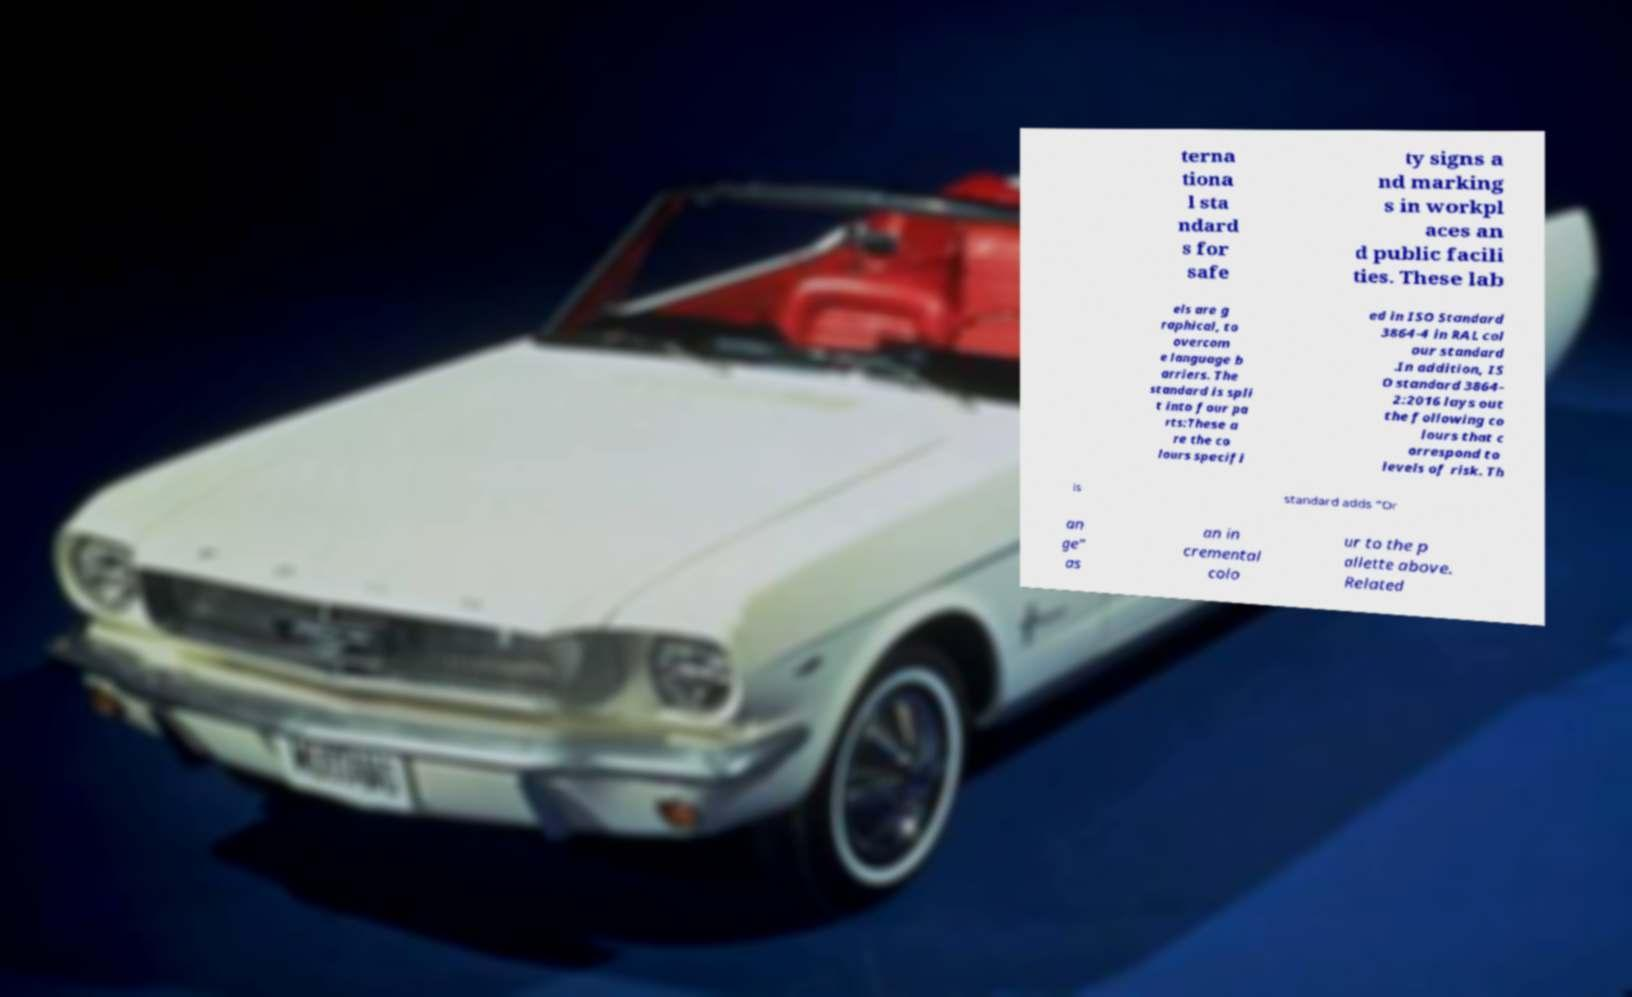For documentation purposes, I need the text within this image transcribed. Could you provide that? terna tiona l sta ndard s for safe ty signs a nd marking s in workpl aces an d public facili ties. These lab els are g raphical, to overcom e language b arriers. The standard is spli t into four pa rts:These a re the co lours specifi ed in ISO Standard 3864-4 in RAL col our standard .In addition, IS O standard 3864- 2:2016 lays out the following co lours that c orrespond to levels of risk. Th is standard adds "Or an ge" as an in cremental colo ur to the p allette above. Related 